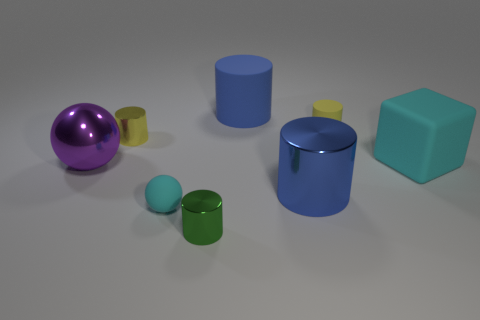What is the thing that is both to the right of the big purple sphere and left of the tiny cyan thing made of?
Provide a short and direct response. Metal. What is the color of the metallic cylinder that is in front of the big blue object in front of the rubber cylinder that is behind the small yellow rubber thing?
Make the answer very short. Green. What color is the shiny cylinder that is the same size as the purple metallic sphere?
Your answer should be very brief. Blue. There is a large cube; does it have the same color as the rubber thing that is to the left of the tiny green shiny cylinder?
Offer a very short reply. Yes. What material is the yellow object that is in front of the tiny rubber thing that is right of the tiny matte sphere?
Offer a terse response. Metal. What number of cylinders are both right of the large matte cylinder and in front of the cyan rubber cube?
Provide a short and direct response. 1. There is a small rubber object that is behind the purple metal ball; is its shape the same as the tiny thing left of the cyan rubber ball?
Your answer should be very brief. Yes. There is a blue matte cylinder; are there any cyan rubber cubes behind it?
Make the answer very short. No. What is the color of the other tiny rubber object that is the same shape as the tiny green object?
Ensure brevity in your answer.  Yellow. Is there any other thing that has the same shape as the large cyan matte thing?
Keep it short and to the point. No. 